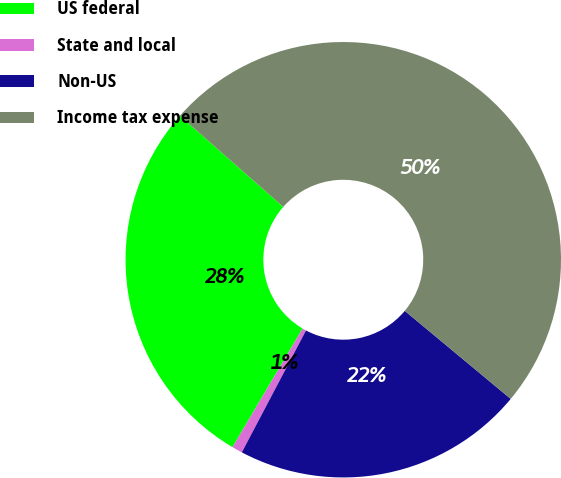<chart> <loc_0><loc_0><loc_500><loc_500><pie_chart><fcel>US federal<fcel>State and local<fcel>Non-US<fcel>Income tax expense<nl><fcel>28.0%<fcel>0.78%<fcel>21.68%<fcel>49.54%<nl></chart> 